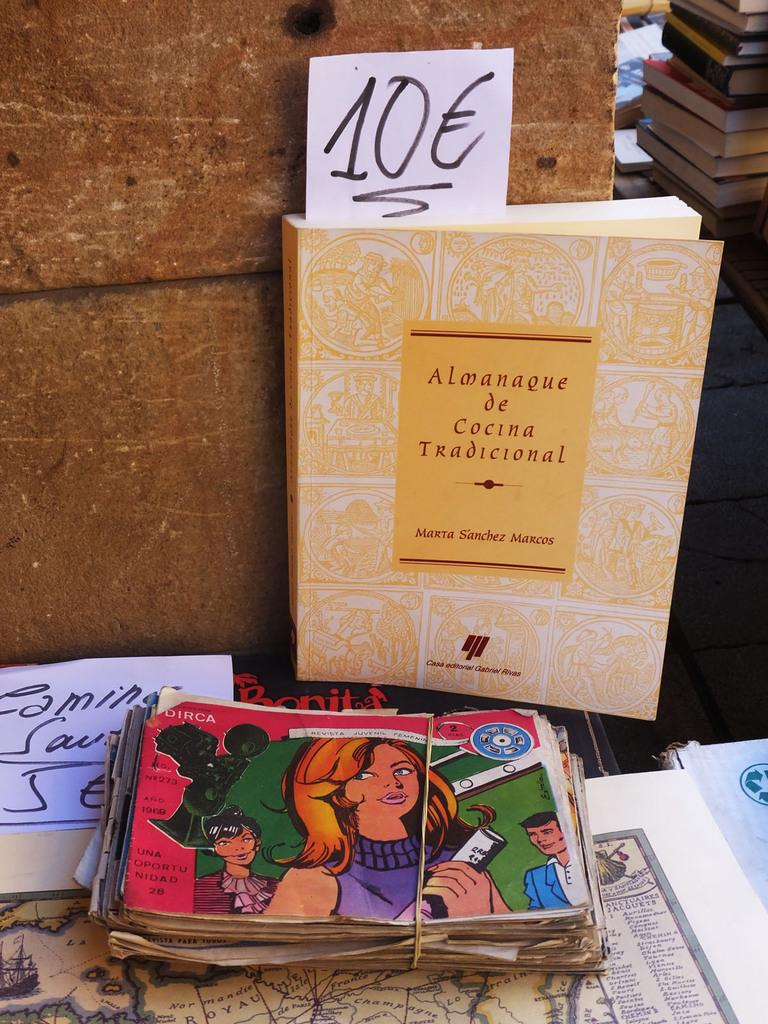Provide a one-sentence caption for the provided image. A book stands tall with the title Almanaque de Cocina Tradicional in the background of a sale. 